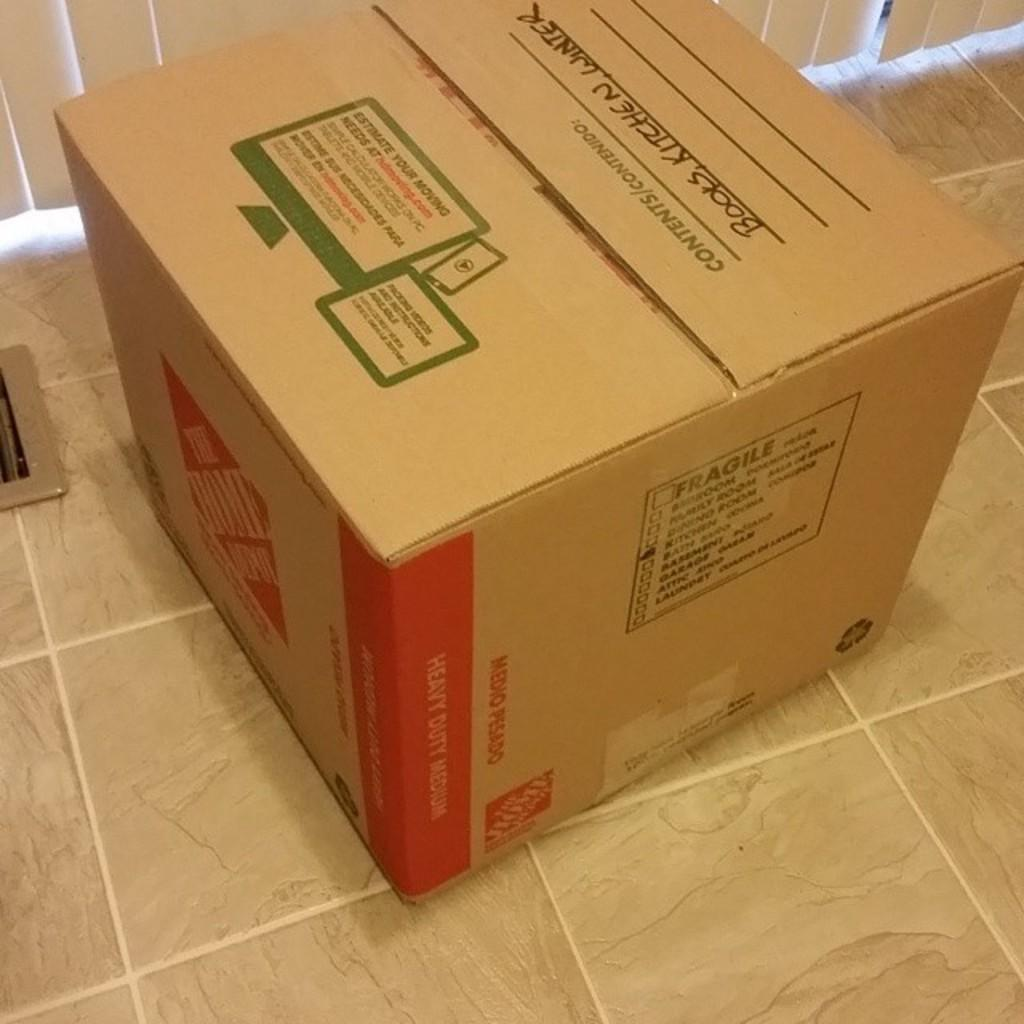Provide a one-sentence caption for the provided image. A brown cardboard box labled in black marker with books,kitchen and winter. 